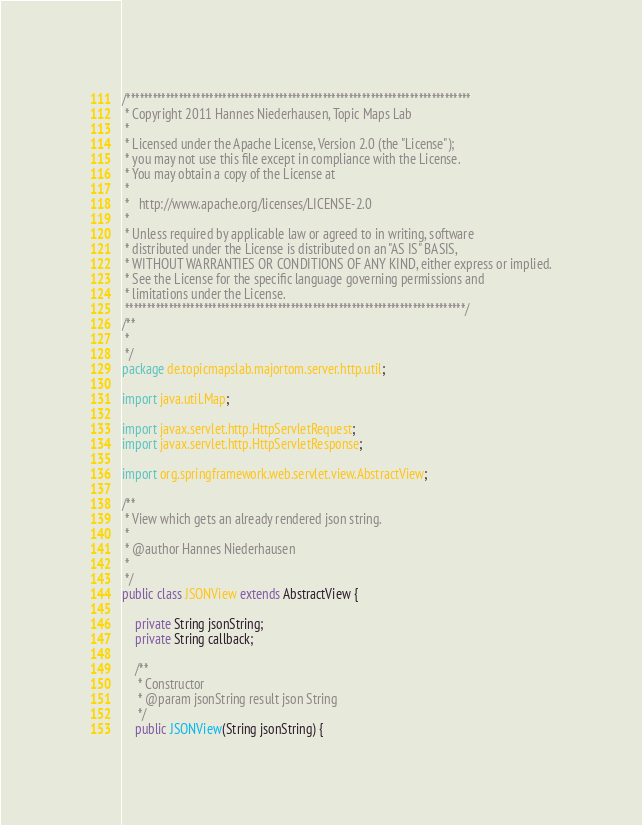<code> <loc_0><loc_0><loc_500><loc_500><_Java_>/*******************************************************************************
 * Copyright 2011 Hannes Niederhausen, Topic Maps Lab
 * 
 * Licensed under the Apache License, Version 2.0 (the "License");
 * you may not use this file except in compliance with the License.
 * You may obtain a copy of the License at
 * 
 *   http://www.apache.org/licenses/LICENSE-2.0
 * 
 * Unless required by applicable law or agreed to in writing, software
 * distributed under the License is distributed on an "AS IS" BASIS,
 * WITHOUT WARRANTIES OR CONDITIONS OF ANY KIND, either express or implied.
 * See the License for the specific language governing permissions and
 * limitations under the License.
 ******************************************************************************/
/**
 * 
 */
package de.topicmapslab.majortom.server.http.util;

import java.util.Map;

import javax.servlet.http.HttpServletRequest;
import javax.servlet.http.HttpServletResponse;

import org.springframework.web.servlet.view.AbstractView;

/**
 * View which gets an already rendered json string.
 * 
 * @author Hannes Niederhausen
 * 
 */
public class JSONView extends AbstractView {

	private String jsonString;
	private String callback;

	/**
	 * Constructor
	 * @param jsonString result json String
	 */
	public JSONView(String jsonString) {</code> 